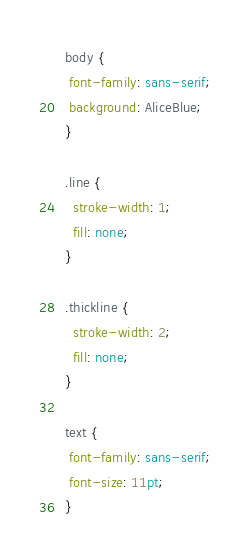<code> <loc_0><loc_0><loc_500><loc_500><_CSS_>
body {
 font-family: sans-serif;
 background: AliceBlue;
}

.line {
  stroke-width: 1;
  fill: none;
}

.thickline {
  stroke-width: 2;
  fill: none;
}

text {
 font-family: sans-serif;
 font-size: 11pt;
}
</code> 